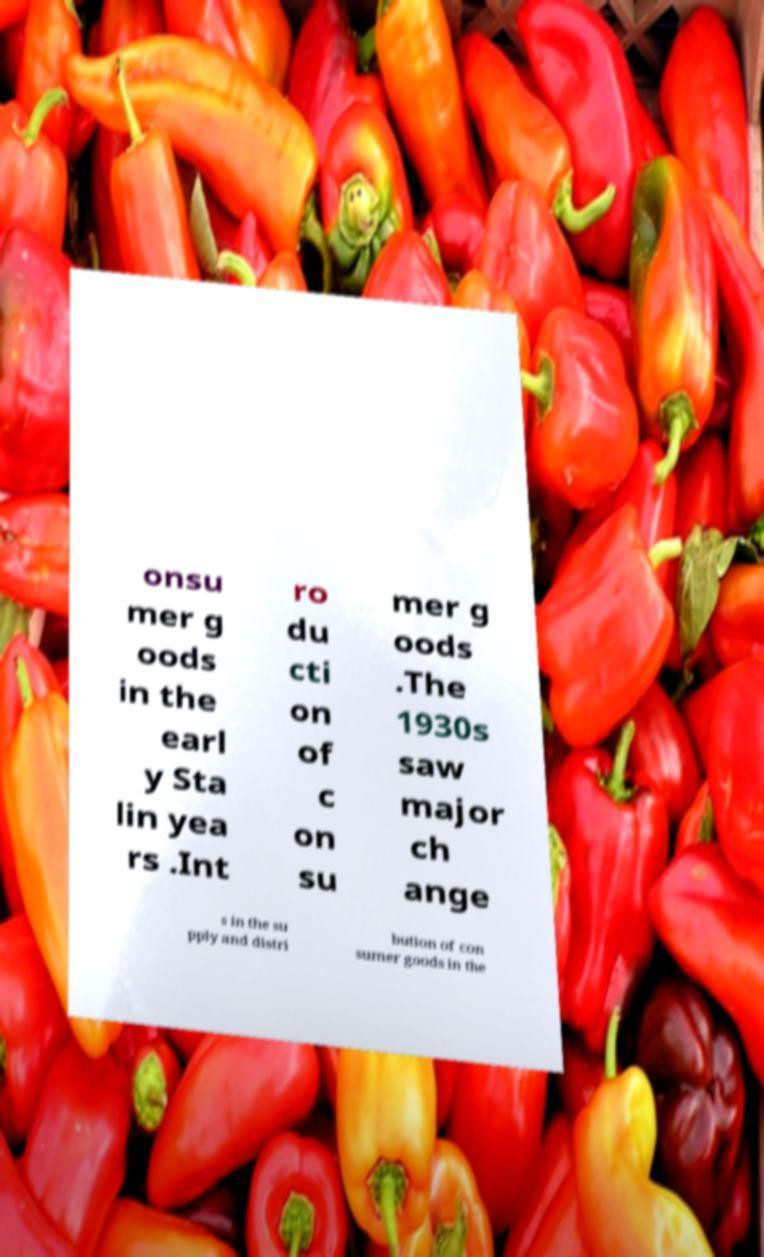Please read and relay the text visible in this image. What does it say? onsu mer g oods in the earl y Sta lin yea rs .Int ro du cti on of c on su mer g oods .The 1930s saw major ch ange s in the su pply and distri bution of con sumer goods in the 